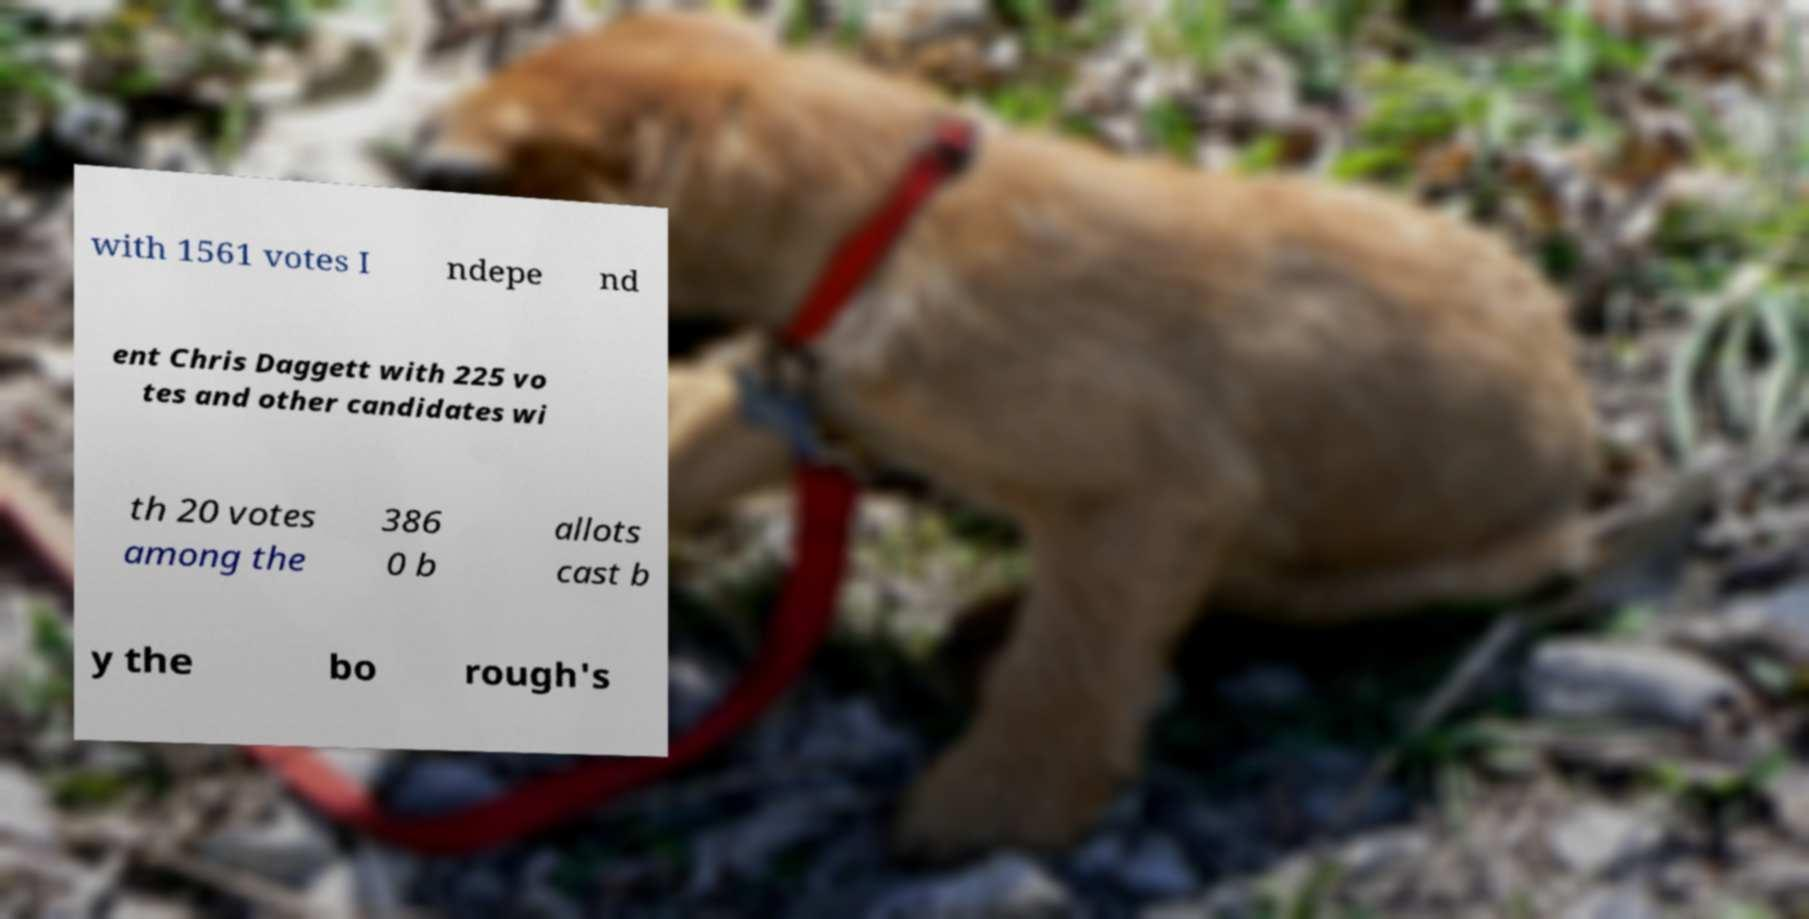Please identify and transcribe the text found in this image. with 1561 votes I ndepe nd ent Chris Daggett with 225 vo tes and other candidates wi th 20 votes among the 386 0 b allots cast b y the bo rough's 